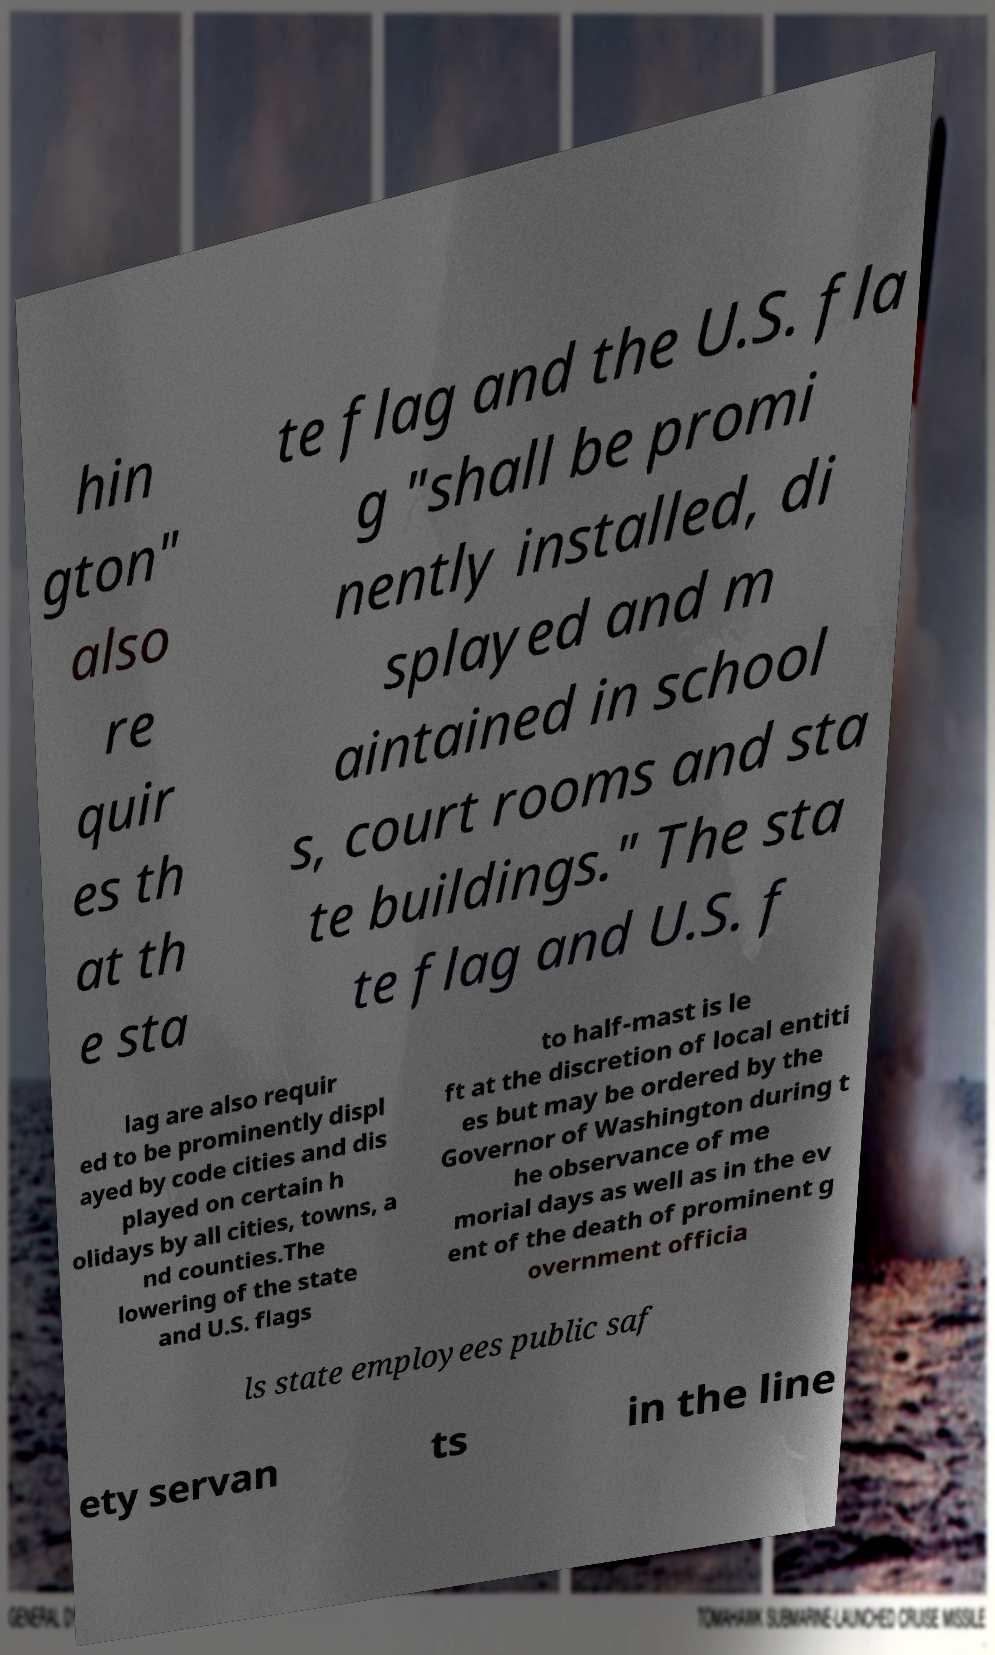Please read and relay the text visible in this image. What does it say? hin gton" also re quir es th at th e sta te flag and the U.S. fla g "shall be promi nently installed, di splayed and m aintained in school s, court rooms and sta te buildings." The sta te flag and U.S. f lag are also requir ed to be prominently displ ayed by code cities and dis played on certain h olidays by all cities, towns, a nd counties.The lowering of the state and U.S. flags to half-mast is le ft at the discretion of local entiti es but may be ordered by the Governor of Washington during t he observance of me morial days as well as in the ev ent of the death of prominent g overnment officia ls state employees public saf ety servan ts in the line 